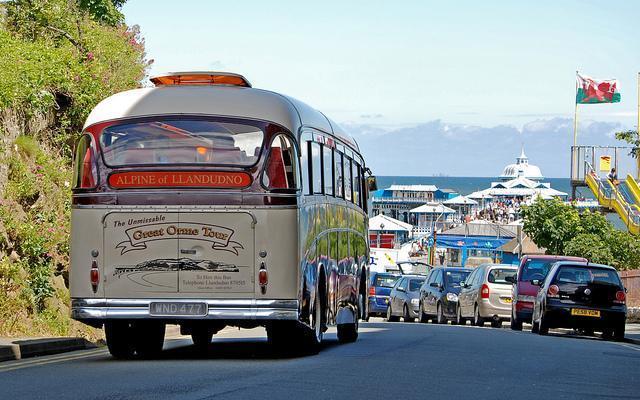How many cars are there?
Give a very brief answer. 4. 